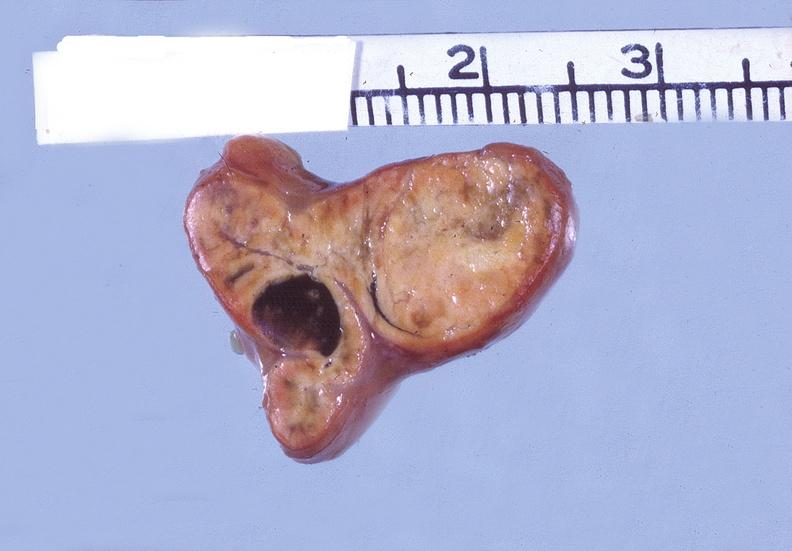s metastatic carcinoma present?
Answer the question using a single word or phrase. No 